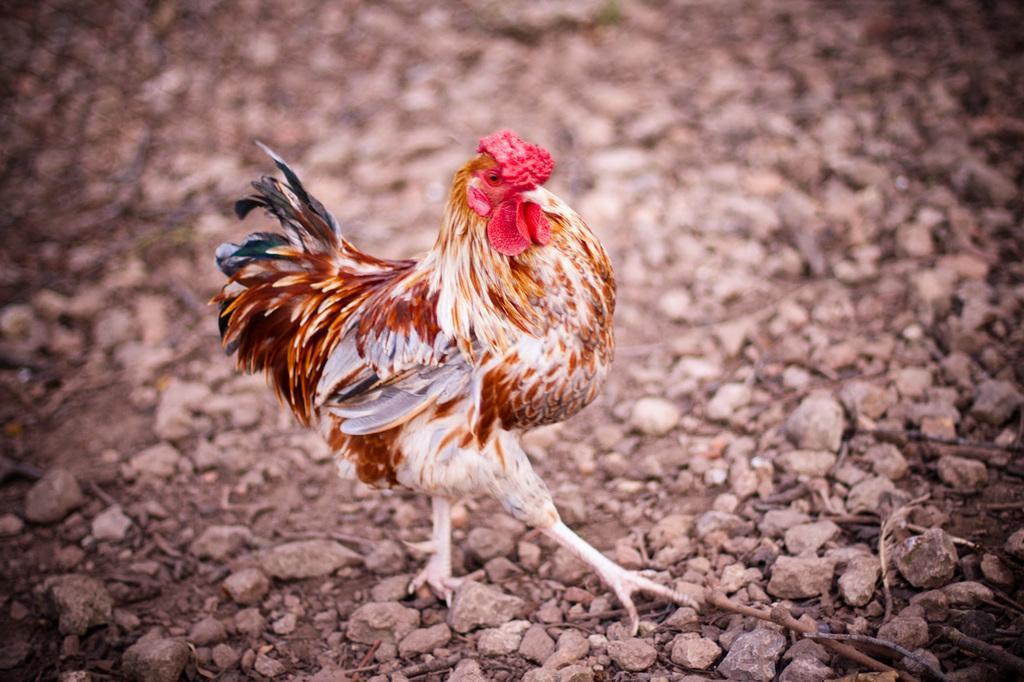In one or two sentences, can you explain what this image depicts? Here we can see a hen walking on the ground and we can also see small stones. 